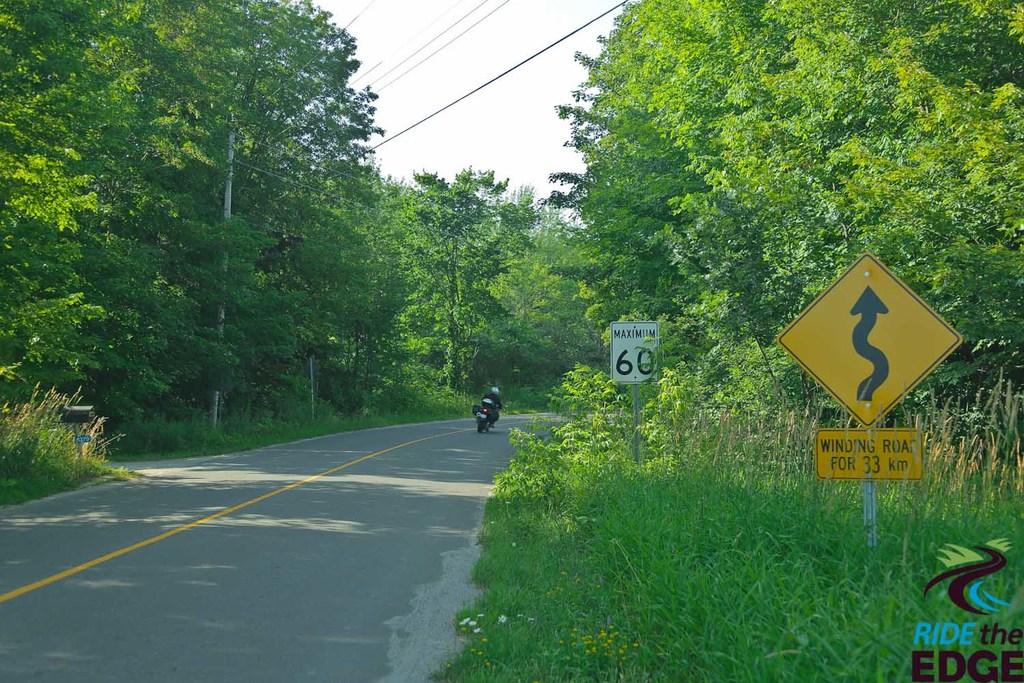What is the speed limit?
Make the answer very short. 60. What is for 33 km?
Offer a very short reply. Winding road. 